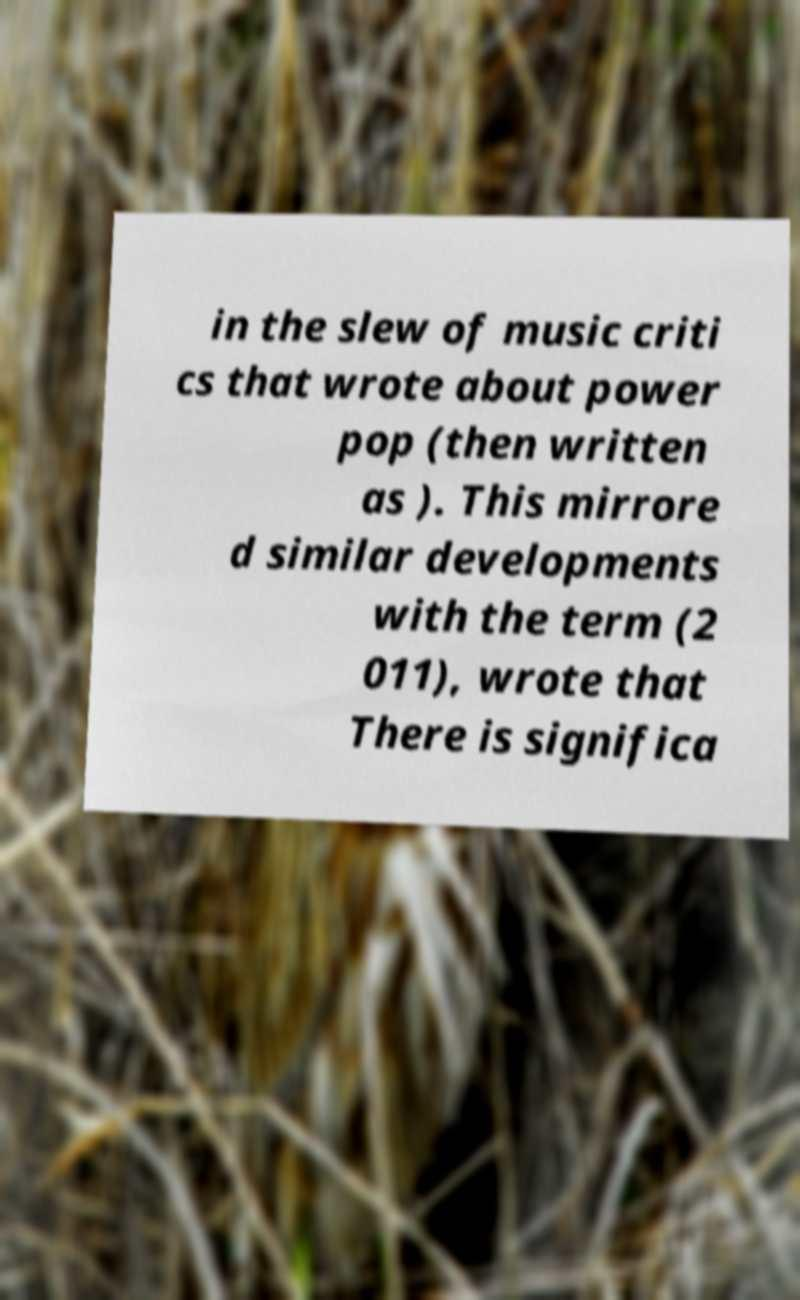Please identify and transcribe the text found in this image. in the slew of music criti cs that wrote about power pop (then written as ). This mirrore d similar developments with the term (2 011), wrote that There is significa 